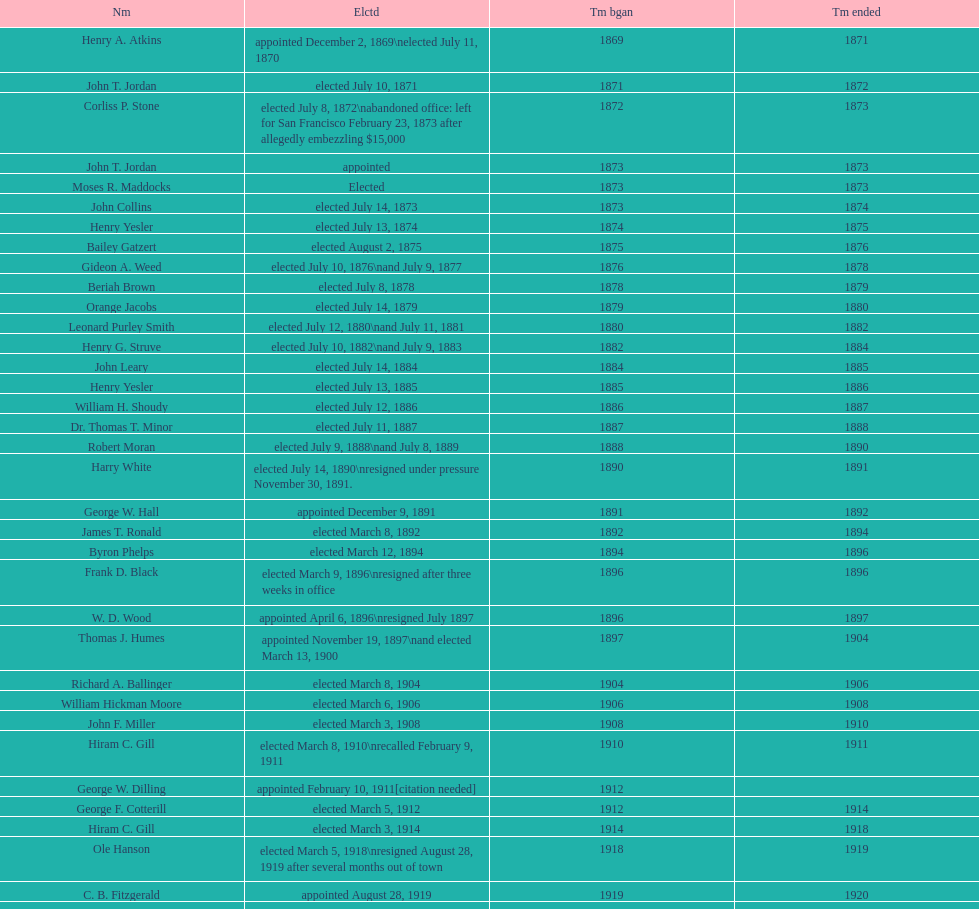During 1871, who was the only one that managed to get elected? John T. Jordan. 